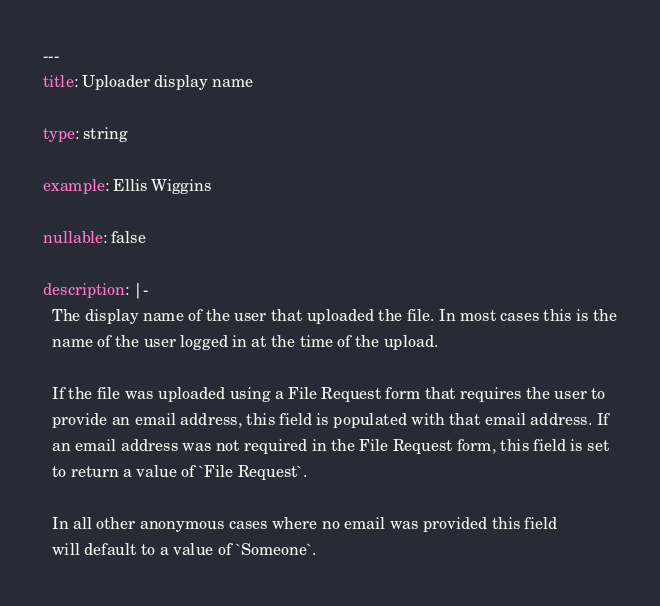Convert code to text. <code><loc_0><loc_0><loc_500><loc_500><_YAML_>---
title: Uploader display name

type: string

example: Ellis Wiggins

nullable: false

description: |-
  The display name of the user that uploaded the file. In most cases this is the
  name of the user logged in at the time of the upload.

  If the file was uploaded using a File Request form that requires the user to
  provide an email address, this field is populated with that email address. If
  an email address was not required in the File Request form, this field is set
  to return a value of `File Request`.

  In all other anonymous cases where no email was provided this field
  will default to a value of `Someone`.
</code> 